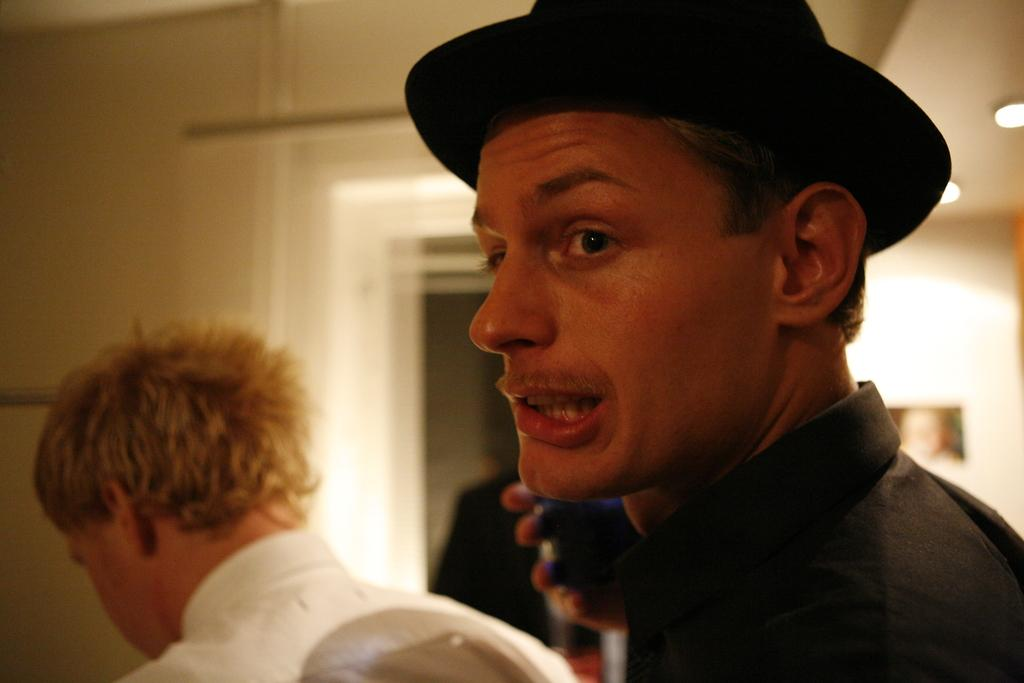How many people are in the image? There are a few people in the image. What is one person doing with their hand? One person is holding an object in their hand. What can be seen behind the people in the image? There is a wall in the background of the image. What is visible above the people in the image? There is a ceiling visible at the top of the image. How many geese are flying across the ceiling in the image? There are no geese present in the image, and therefore no such activity can be observed. 